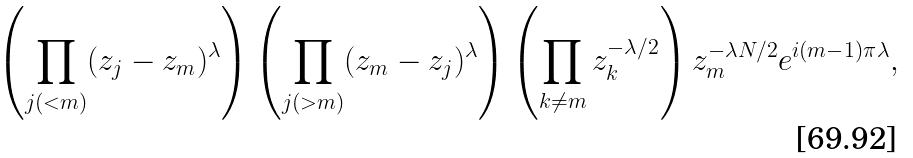Convert formula to latex. <formula><loc_0><loc_0><loc_500><loc_500>\left ( \prod _ { j ( < m ) } ( z _ { j } - z _ { m } ) ^ { \lambda } \right ) \left ( \prod _ { j ( > m ) } ( z _ { m } - z _ { j } ) ^ { \lambda } \right ) \left ( \prod _ { k \ne m } z _ { k } ^ { - \lambda / 2 } \right ) z _ { m } ^ { - \lambda N / 2 } e ^ { i ( m - 1 ) \pi \lambda } ,</formula> 